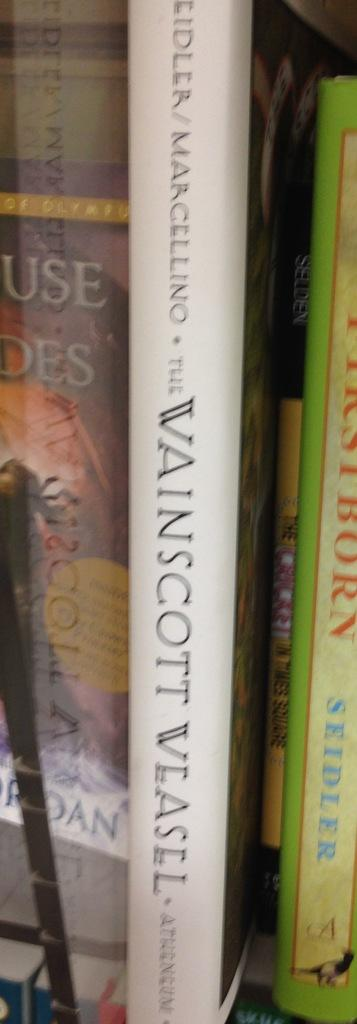<image>
Write a terse but informative summary of the picture. a book with the author Wainscott on the side of it 